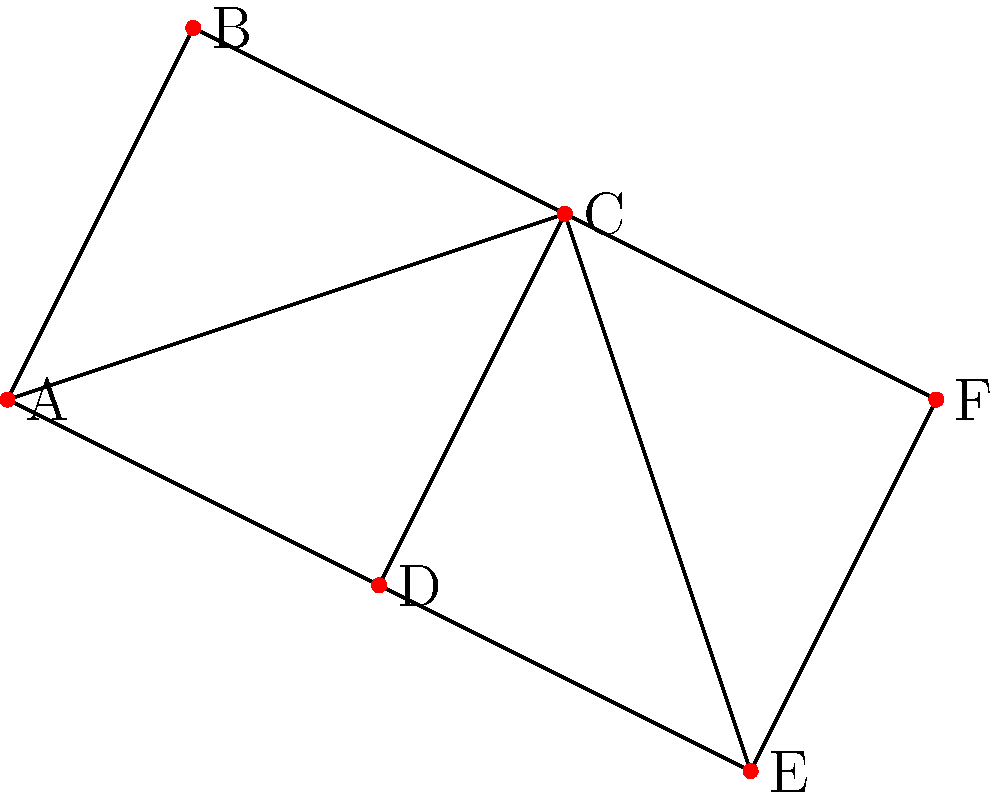As the dean overseeing campus development, you're tasked with optimizing the university's transportation system. The graph represents key locations on campus, with edges indicating direct routes between them. What is the minimum number of surveillance cameras needed to monitor all routes if each camera can observe all routes connected to a single location? To solve this problem, we need to find the minimum vertex cover of the graph. A vertex cover is a set of vertices such that every edge in the graph is incident to at least one vertex in the set. The steps to determine this are:

1. Identify the degree (number of connections) of each vertex:
   A: 3, B: 2, C: 5, D: 3, E: 3, F: 2

2. Select the vertex with the highest degree (C) and add it to the cover.

3. Remove all edges connected to C from consideration.

4. Repeat steps 2-3 until all edges are covered.

5. After selecting C, we're left with edges A-B and D-E.

6. We can cover these remaining edges by selecting either A or D.

7. Choosing A covers A-B, and D-E is the only remaining edge.

8. Select E to cover the final edge.

Therefore, the minimum vertex cover consists of vertices C, A, and E, requiring 3 cameras.

This solution ensures that every route (edge) in the campus is monitored by at least one camera, while using the minimum number of cameras possible.
Answer: 3 cameras 